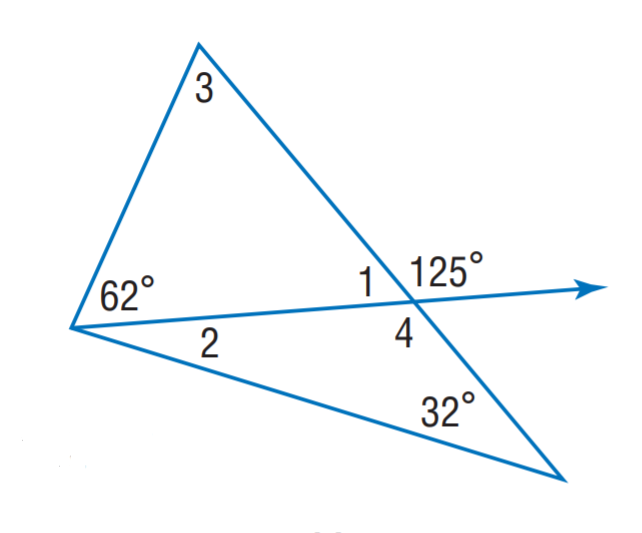Question: Find m \angle 1.
Choices:
A. 23
B. 55
C. 63
D. 125
Answer with the letter. Answer: B Question: Find m \angle 4.
Choices:
A. 55
B. 63
C. 118
D. 125
Answer with the letter. Answer: D Question: Find m \angle 2.
Choices:
A. 23
B. 55
C. 63
D. 125
Answer with the letter. Answer: A 